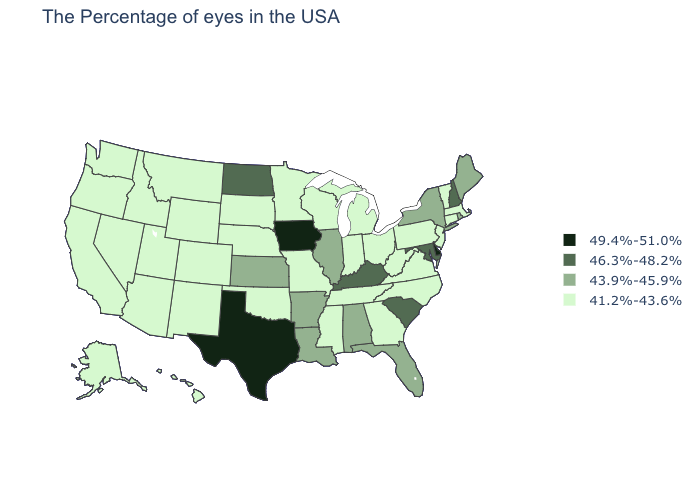Name the states that have a value in the range 43.9%-45.9%?
Give a very brief answer. Maine, Rhode Island, New York, Florida, Alabama, Illinois, Louisiana, Arkansas, Kansas. Does the first symbol in the legend represent the smallest category?
Short answer required. No. Among the states that border Georgia , which have the lowest value?
Answer briefly. North Carolina, Tennessee. What is the highest value in the West ?
Write a very short answer. 41.2%-43.6%. Among the states that border Michigan , which have the lowest value?
Write a very short answer. Ohio, Indiana, Wisconsin. What is the highest value in the USA?
Write a very short answer. 49.4%-51.0%. Name the states that have a value in the range 43.9%-45.9%?
Quick response, please. Maine, Rhode Island, New York, Florida, Alabama, Illinois, Louisiana, Arkansas, Kansas. Among the states that border Ohio , which have the highest value?
Short answer required. Kentucky. What is the value of Kentucky?
Keep it brief. 46.3%-48.2%. What is the value of Kentucky?
Write a very short answer. 46.3%-48.2%. What is the value of Tennessee?
Write a very short answer. 41.2%-43.6%. Name the states that have a value in the range 46.3%-48.2%?
Concise answer only. New Hampshire, Maryland, South Carolina, Kentucky, North Dakota. Name the states that have a value in the range 41.2%-43.6%?
Answer briefly. Massachusetts, Vermont, Connecticut, New Jersey, Pennsylvania, Virginia, North Carolina, West Virginia, Ohio, Georgia, Michigan, Indiana, Tennessee, Wisconsin, Mississippi, Missouri, Minnesota, Nebraska, Oklahoma, South Dakota, Wyoming, Colorado, New Mexico, Utah, Montana, Arizona, Idaho, Nevada, California, Washington, Oregon, Alaska, Hawaii. 